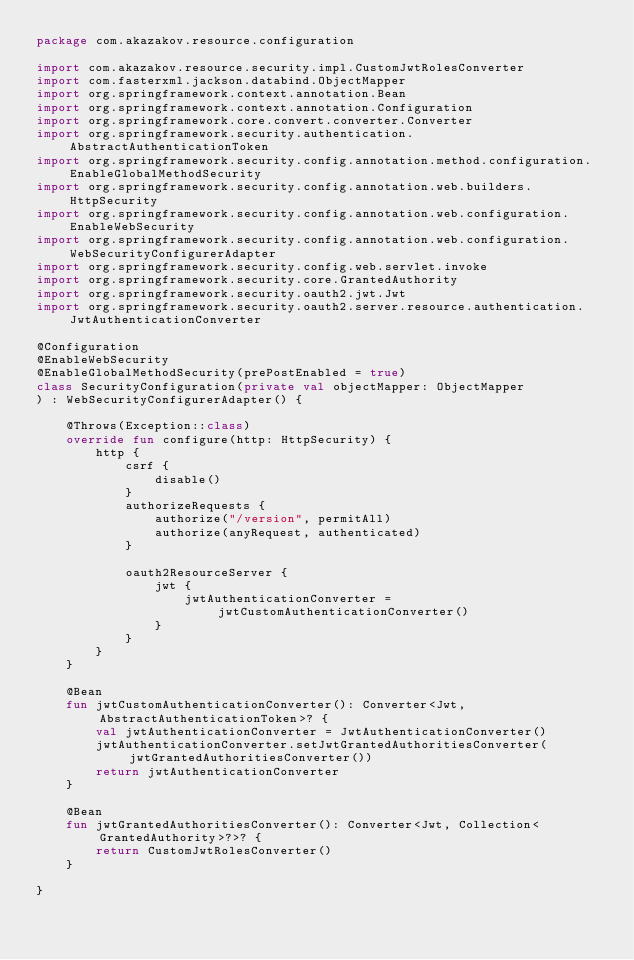Convert code to text. <code><loc_0><loc_0><loc_500><loc_500><_Kotlin_>package com.akazakov.resource.configuration

import com.akazakov.resource.security.impl.CustomJwtRolesConverter
import com.fasterxml.jackson.databind.ObjectMapper
import org.springframework.context.annotation.Bean
import org.springframework.context.annotation.Configuration
import org.springframework.core.convert.converter.Converter
import org.springframework.security.authentication.AbstractAuthenticationToken
import org.springframework.security.config.annotation.method.configuration.EnableGlobalMethodSecurity
import org.springframework.security.config.annotation.web.builders.HttpSecurity
import org.springframework.security.config.annotation.web.configuration.EnableWebSecurity
import org.springframework.security.config.annotation.web.configuration.WebSecurityConfigurerAdapter
import org.springframework.security.config.web.servlet.invoke
import org.springframework.security.core.GrantedAuthority
import org.springframework.security.oauth2.jwt.Jwt
import org.springframework.security.oauth2.server.resource.authentication.JwtAuthenticationConverter

@Configuration
@EnableWebSecurity
@EnableGlobalMethodSecurity(prePostEnabled = true)
class SecurityConfiguration(private val objectMapper: ObjectMapper
) : WebSecurityConfigurerAdapter() {

    @Throws(Exception::class)
    override fun configure(http: HttpSecurity) {
        http {
            csrf {
                disable()
            }
            authorizeRequests {
                authorize("/version", permitAll)
                authorize(anyRequest, authenticated)
            }

            oauth2ResourceServer {
                jwt {
                    jwtAuthenticationConverter = jwtCustomAuthenticationConverter()
                }
            }
        }
    }

    @Bean
    fun jwtCustomAuthenticationConverter(): Converter<Jwt, AbstractAuthenticationToken>? {
        val jwtAuthenticationConverter = JwtAuthenticationConverter()
        jwtAuthenticationConverter.setJwtGrantedAuthoritiesConverter(jwtGrantedAuthoritiesConverter())
        return jwtAuthenticationConverter
    }

    @Bean
    fun jwtGrantedAuthoritiesConverter(): Converter<Jwt, Collection<GrantedAuthority>?>? {
        return CustomJwtRolesConverter()
    }

}</code> 